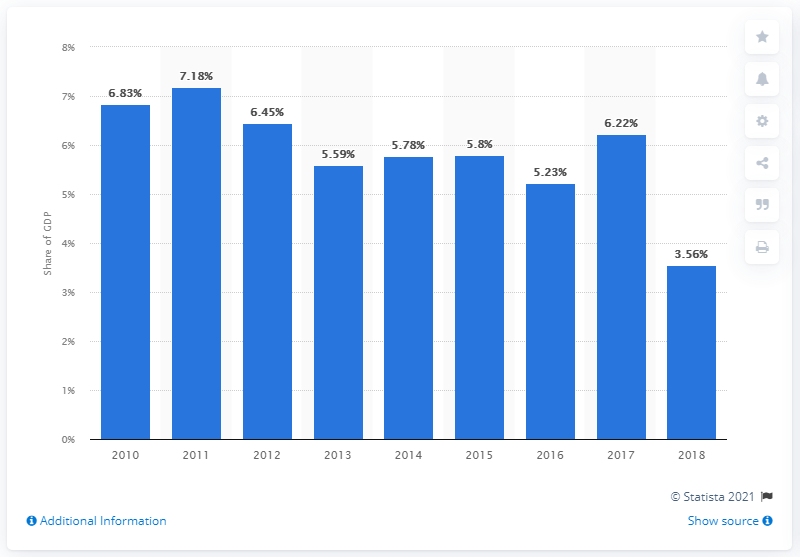Highlight a few significant elements in this photo. In 2018, Venezuela had the lowest health care expenditure among all countries in Latin America. 